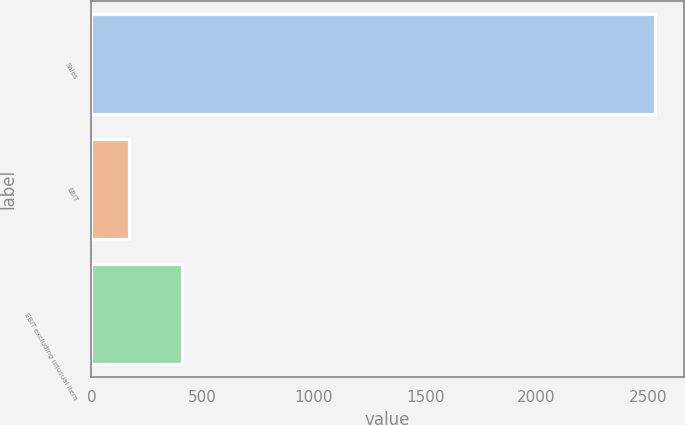Convert chart to OTSL. <chart><loc_0><loc_0><loc_500><loc_500><bar_chart><fcel>Sales<fcel>EBIT<fcel>EBIT excluding unusual item<nl><fcel>2534<fcel>171<fcel>407.3<nl></chart> 